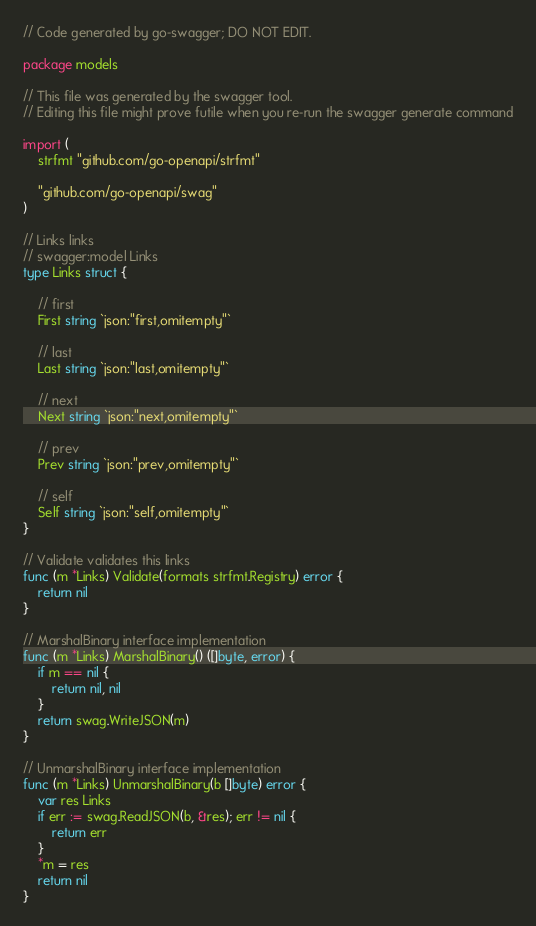Convert code to text. <code><loc_0><loc_0><loc_500><loc_500><_Go_>// Code generated by go-swagger; DO NOT EDIT.

package models

// This file was generated by the swagger tool.
// Editing this file might prove futile when you re-run the swagger generate command

import (
	strfmt "github.com/go-openapi/strfmt"

	"github.com/go-openapi/swag"
)

// Links links
// swagger:model Links
type Links struct {

	// first
	First string `json:"first,omitempty"`

	// last
	Last string `json:"last,omitempty"`

	// next
	Next string `json:"next,omitempty"`

	// prev
	Prev string `json:"prev,omitempty"`

	// self
	Self string `json:"self,omitempty"`
}

// Validate validates this links
func (m *Links) Validate(formats strfmt.Registry) error {
	return nil
}

// MarshalBinary interface implementation
func (m *Links) MarshalBinary() ([]byte, error) {
	if m == nil {
		return nil, nil
	}
	return swag.WriteJSON(m)
}

// UnmarshalBinary interface implementation
func (m *Links) UnmarshalBinary(b []byte) error {
	var res Links
	if err := swag.ReadJSON(b, &res); err != nil {
		return err
	}
	*m = res
	return nil
}
</code> 